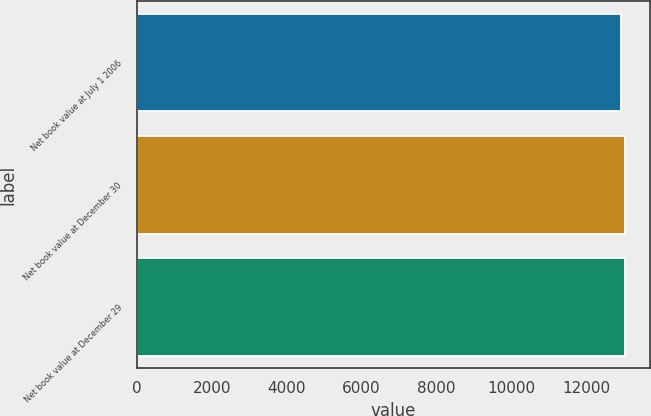Convert chart to OTSL. <chart><loc_0><loc_0><loc_500><loc_500><bar_chart><fcel>Net book value at July 1 2006<fcel>Net book value at December 30<fcel>Net book value at December 29<nl><fcel>12943<fcel>13047<fcel>13031<nl></chart> 